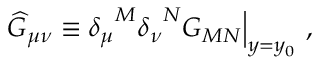<formula> <loc_0><loc_0><loc_500><loc_500>{ \widehat { G } } _ { \mu \nu } \equiv \delta _ { \mu } ^ { M } { \delta _ { \nu } } ^ { N } G _ { M N } \Big | _ { y = y _ { 0 } } ,</formula> 